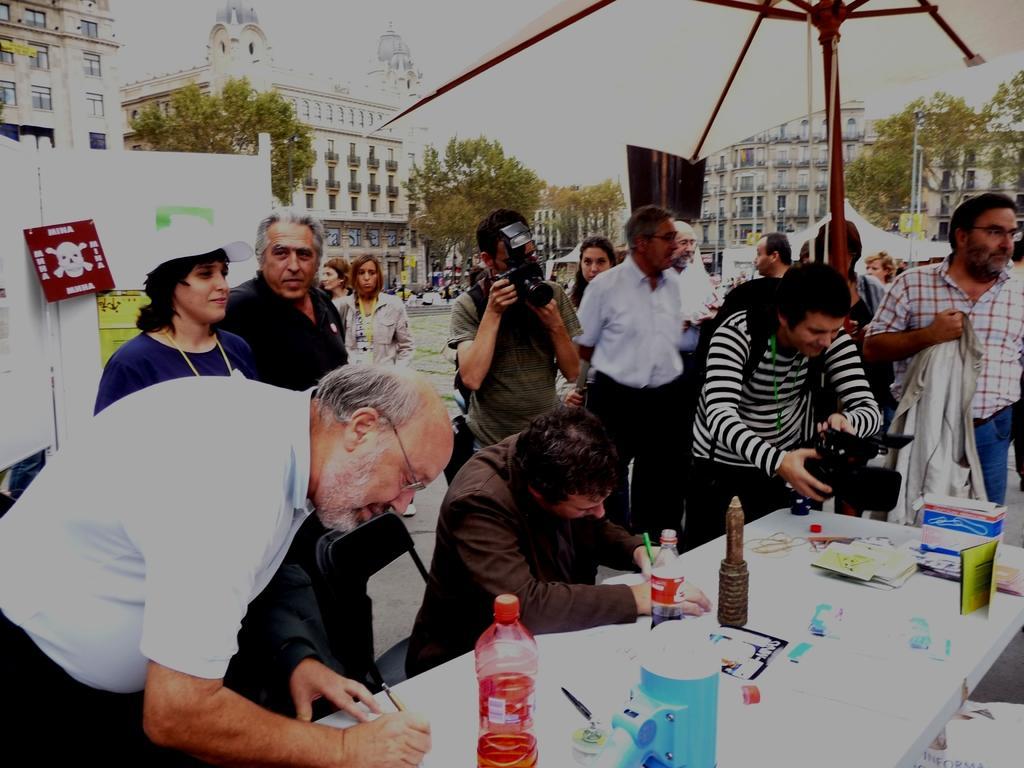Could you give a brief overview of what you see in this image? This is a picture taken in the outdoors. There are group of people standing on the floor and two people are holding cameras and a man in brown shirt was sitting on a chair. In front of the people there is a table on the table there are bottles, jar, papers and boxes. Behind the people there is a board with a danger sign board, trees, building and sky. 